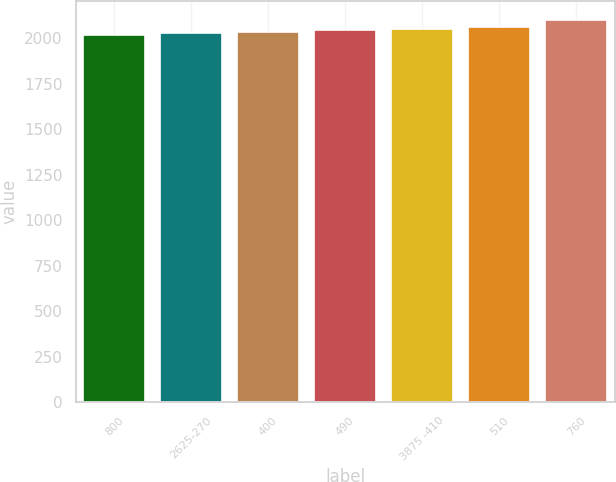<chart> <loc_0><loc_0><loc_500><loc_500><bar_chart><fcel>800<fcel>2625-270<fcel>400<fcel>490<fcel>3875 -410<fcel>510<fcel>760<nl><fcel>2019<fcel>2026.9<fcel>2034.8<fcel>2042.7<fcel>2050.6<fcel>2058.5<fcel>2098<nl></chart> 